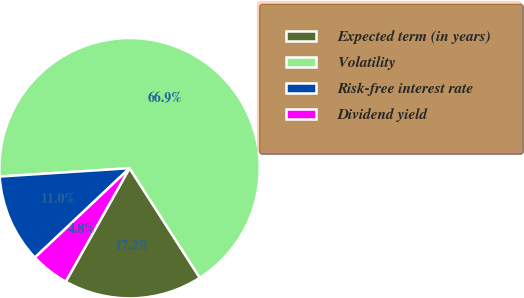Convert chart. <chart><loc_0><loc_0><loc_500><loc_500><pie_chart><fcel>Expected term (in years)<fcel>Volatility<fcel>Risk-free interest rate<fcel>Dividend yield<nl><fcel>17.23%<fcel>66.95%<fcel>11.02%<fcel>4.8%<nl></chart> 